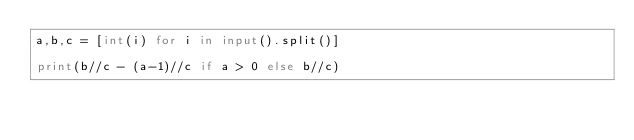Convert code to text. <code><loc_0><loc_0><loc_500><loc_500><_Python_>a,b,c = [int(i) for i in input().split()]

print(b//c - (a-1)//c if a > 0 else b//c)</code> 